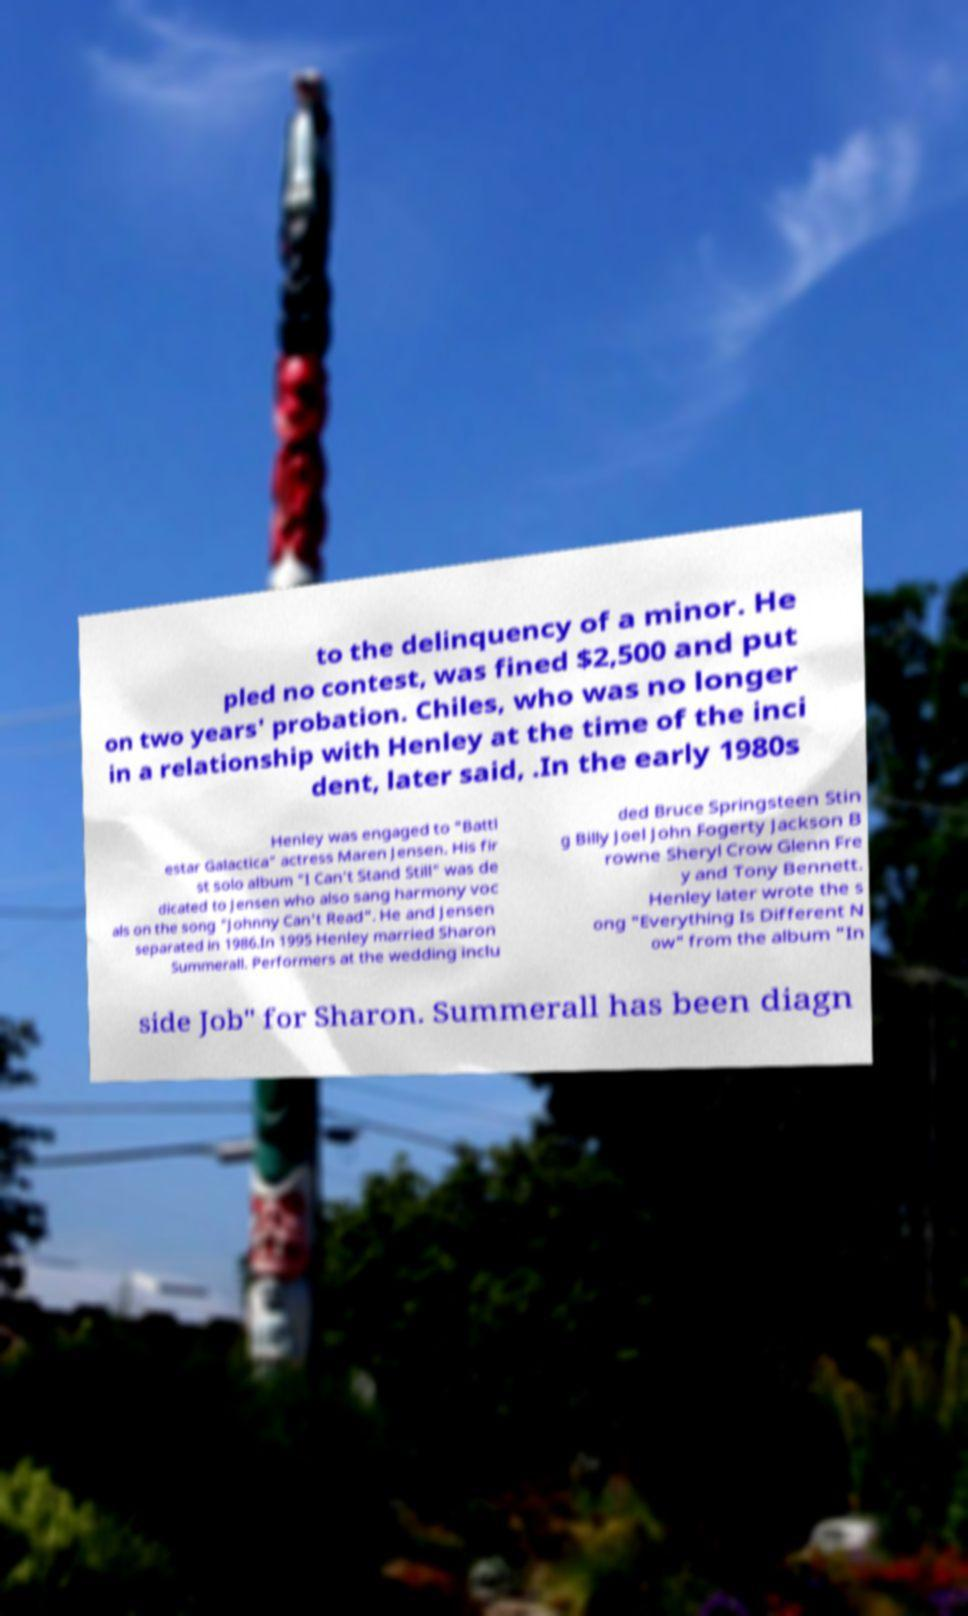Could you extract and type out the text from this image? to the delinquency of a minor. He pled no contest, was fined $2,500 and put on two years' probation. Chiles, who was no longer in a relationship with Henley at the time of the inci dent, later said, .In the early 1980s Henley was engaged to "Battl estar Galactica" actress Maren Jensen. His fir st solo album "I Can't Stand Still" was de dicated to Jensen who also sang harmony voc als on the song "Johnny Can't Read". He and Jensen separated in 1986.In 1995 Henley married Sharon Summerall. Performers at the wedding inclu ded Bruce Springsteen Stin g Billy Joel John Fogerty Jackson B rowne Sheryl Crow Glenn Fre y and Tony Bennett. Henley later wrote the s ong "Everything Is Different N ow" from the album "In side Job" for Sharon. Summerall has been diagn 